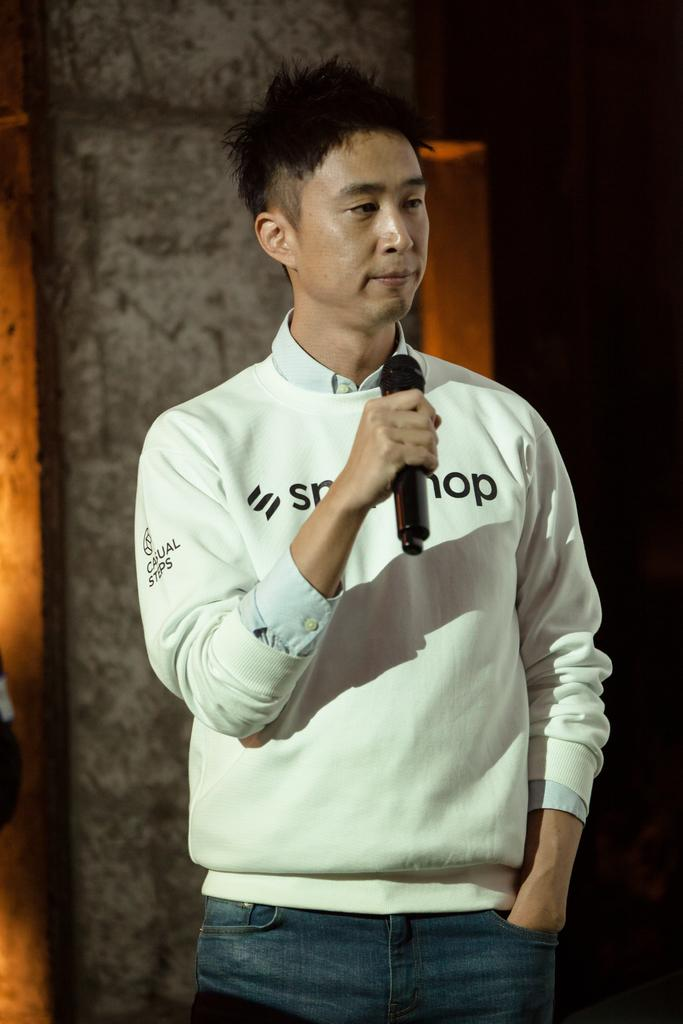What is the main subject of the image? There is a person in the image. What is the person doing in the image? The person is standing in the image. What object is the person holding in the image? The person is holding a microphone in the image. What can be seen in the background of the image? There is a wall in the background of the image. How many sheep are visible in the image? There are no sheep present in the image. Is there a zipper on the person's clothing in the image? The provided facts do not mention any zippers on the person's clothing, so we cannot determine if there is one or not. What type of sack is the person carrying in the image? There is no sack present in the image. 